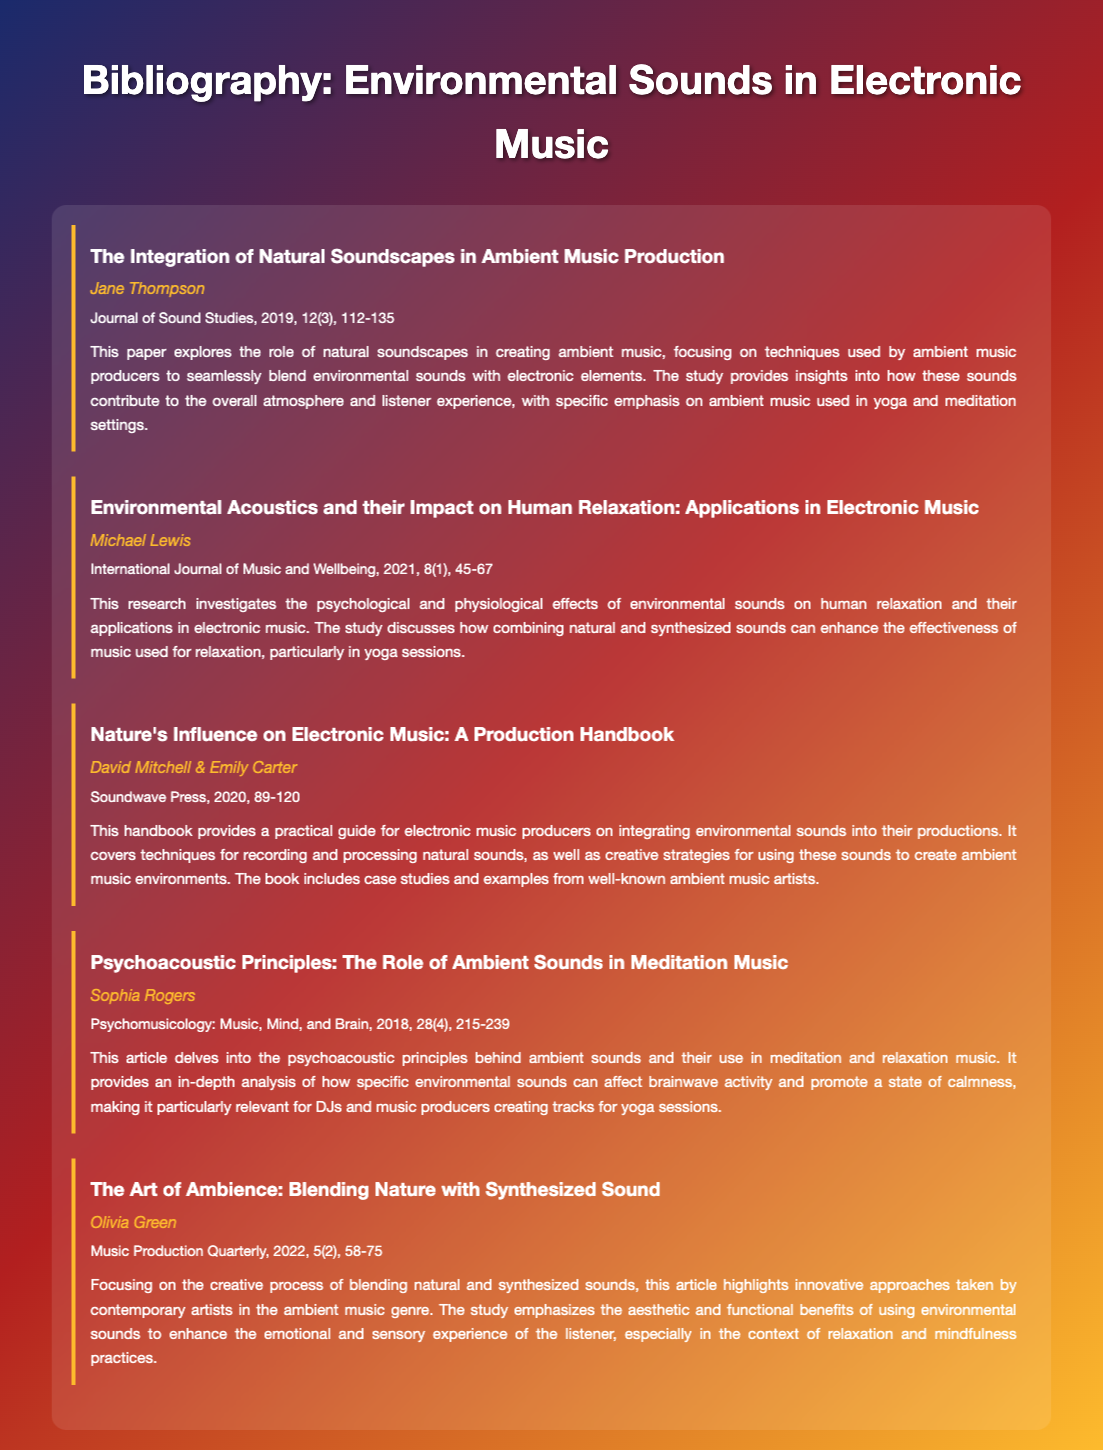What is the title of the first entry? The title of the first entry is explicitly stated in the document, which is "The Integration of Natural Soundscapes in Ambient Music Production."
Answer: The Integration of Natural Soundscapes in Ambient Music Production Who authored the paper on environmental acoustics? The document lists the author of the second entry, which is related to environmental acoustics, as Michael Lewis.
Answer: Michael Lewis In what year was the handbook "Nature's Influence on Electronic Music" published? The publication date for the handbook provided in the document is directly mentioned as 2020.
Answer: 2020 What is the main focus of Sophia Rogers' article? The document describes that Sophia Rogers' article delves into psychoacoustic principles related to ambient sounds and medicine music.
Answer: Psychoacoustic principles Which publication features the article "The Art of Ambience"? According to the document, "The Art of Ambience" article is featured in Music Production Quarterly.
Answer: Music Production Quarterly How many total entries are listed in the bibliography? The document enumerates the entries, stating there are five entries in total.
Answer: Five What psychological effects do environmental sounds have according to Michael Lewis' research? The document indicates that environmental sounds have psychological and physiological effects on human relaxation.
Answer: Human relaxation What volume and issue number is the article by Sophia Rogers published in? The details mentioned in the document state that Sophia Rogers' article is in volume 28, issue 4 of the journal.
Answer: 28(4) 